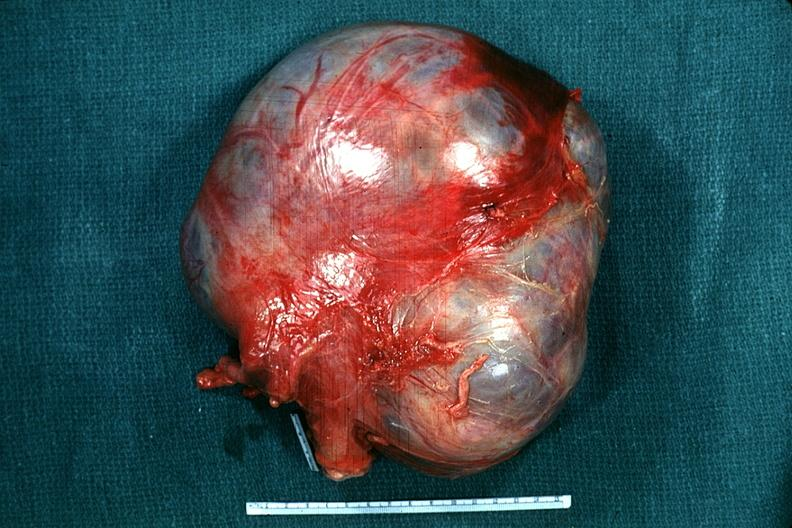what does this image show?
Answer the question using a single word or phrase. External view typical appearance 